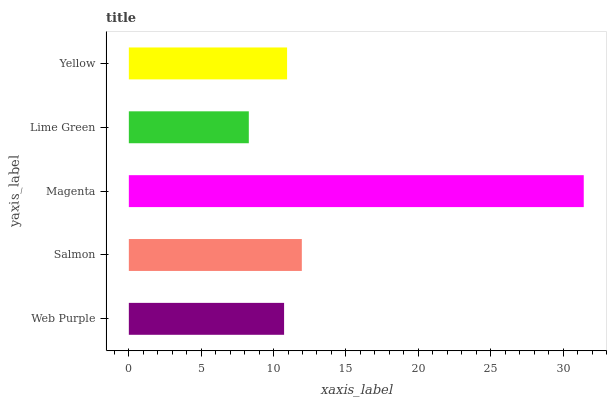Is Lime Green the minimum?
Answer yes or no. Yes. Is Magenta the maximum?
Answer yes or no. Yes. Is Salmon the minimum?
Answer yes or no. No. Is Salmon the maximum?
Answer yes or no. No. Is Salmon greater than Web Purple?
Answer yes or no. Yes. Is Web Purple less than Salmon?
Answer yes or no. Yes. Is Web Purple greater than Salmon?
Answer yes or no. No. Is Salmon less than Web Purple?
Answer yes or no. No. Is Yellow the high median?
Answer yes or no. Yes. Is Yellow the low median?
Answer yes or no. Yes. Is Lime Green the high median?
Answer yes or no. No. Is Lime Green the low median?
Answer yes or no. No. 